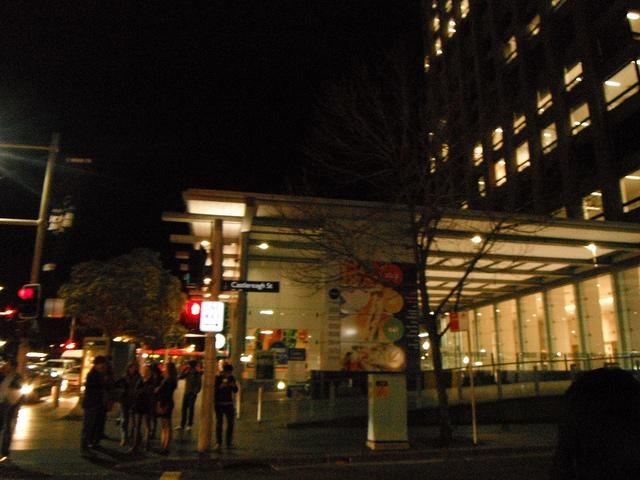What are the people waiting to do? cross street 